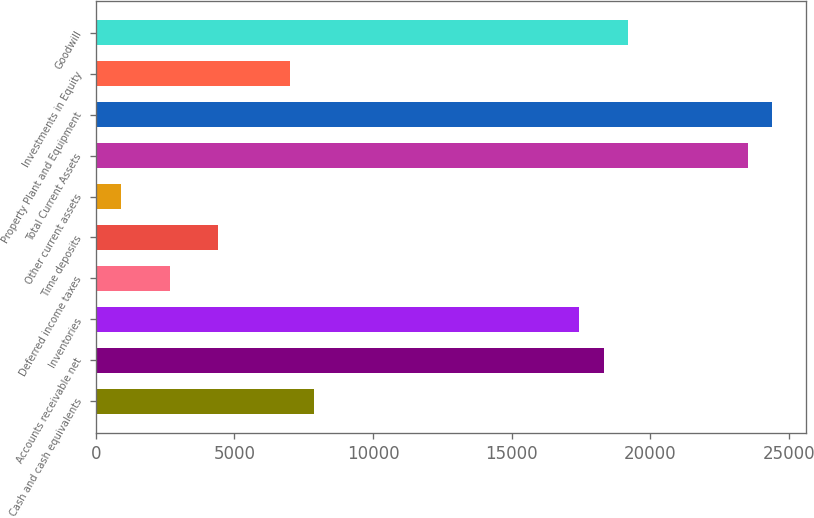Convert chart. <chart><loc_0><loc_0><loc_500><loc_500><bar_chart><fcel>Cash and cash equivalents<fcel>Accounts receivable net<fcel>Inventories<fcel>Deferred income taxes<fcel>Time deposits<fcel>Other current assets<fcel>Total Current Assets<fcel>Property Plant and Equipment<fcel>Investments in Equity<fcel>Goodwill<nl><fcel>7878.61<fcel>18308.9<fcel>17439.7<fcel>2663.47<fcel>4401.85<fcel>925.09<fcel>23524<fcel>24393.2<fcel>7009.42<fcel>19178.1<nl></chart> 